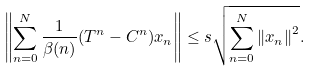<formula> <loc_0><loc_0><loc_500><loc_500>\left \| \sum _ { n = 0 } ^ { N } \frac { 1 } { \beta ( n ) } ( T ^ { n } - C ^ { n } ) x _ { n } \right \| \leq s \sqrt { \sum _ { n = 0 } ^ { N } \left \| x _ { n } \right \| ^ { 2 } } .</formula> 